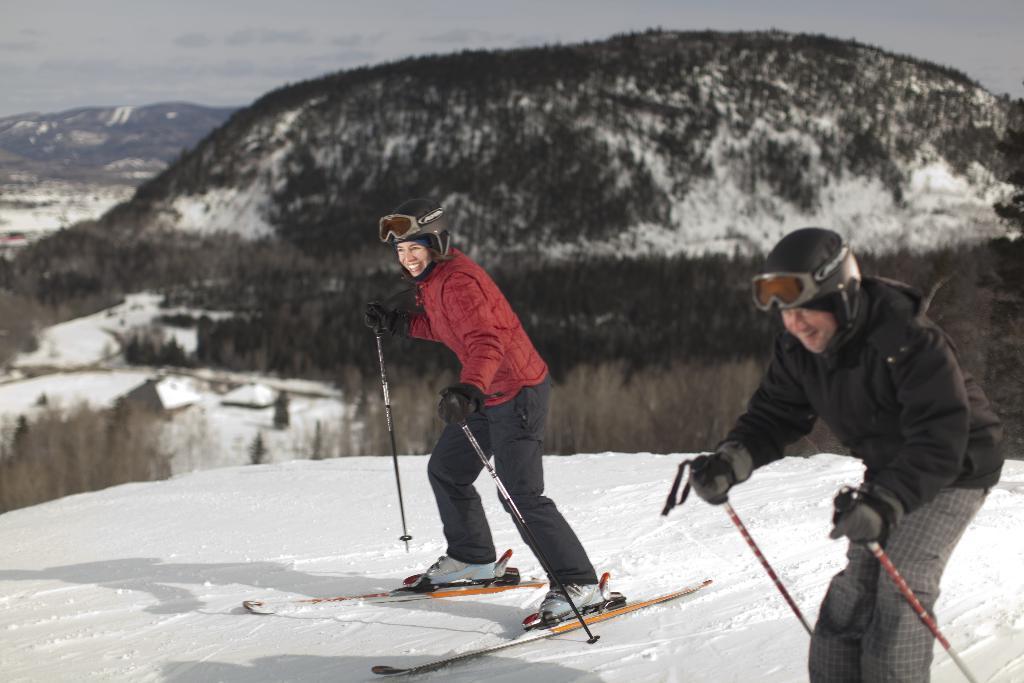Could you give a brief overview of what you see in this image? In this image we can see a man and a woman skiing on the snow holding the sticks. On the backside we can see a group of trees, the ice hills and the sky which looks cloudy. 